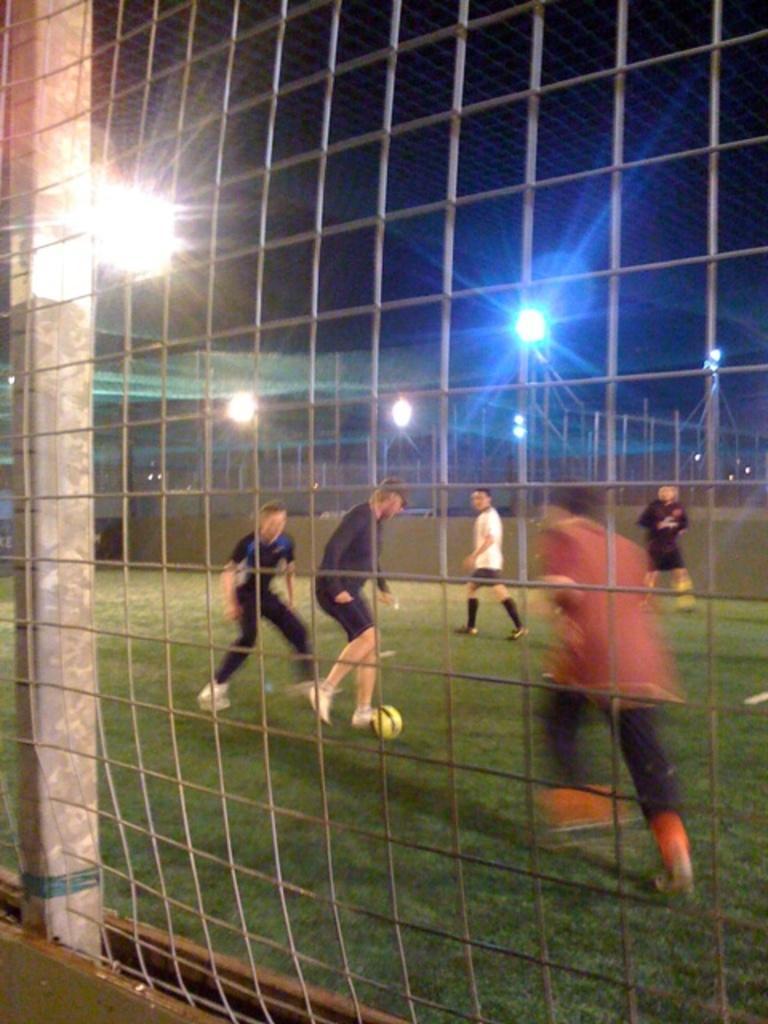Describe this image in one or two sentences. This image is taken outdoors. In the middle of the image there is a mesh. Through the mesh we can see there is a pole. There is a ground with grass on it and a few men are playing football with a ball. There are a few poles with street lights. 